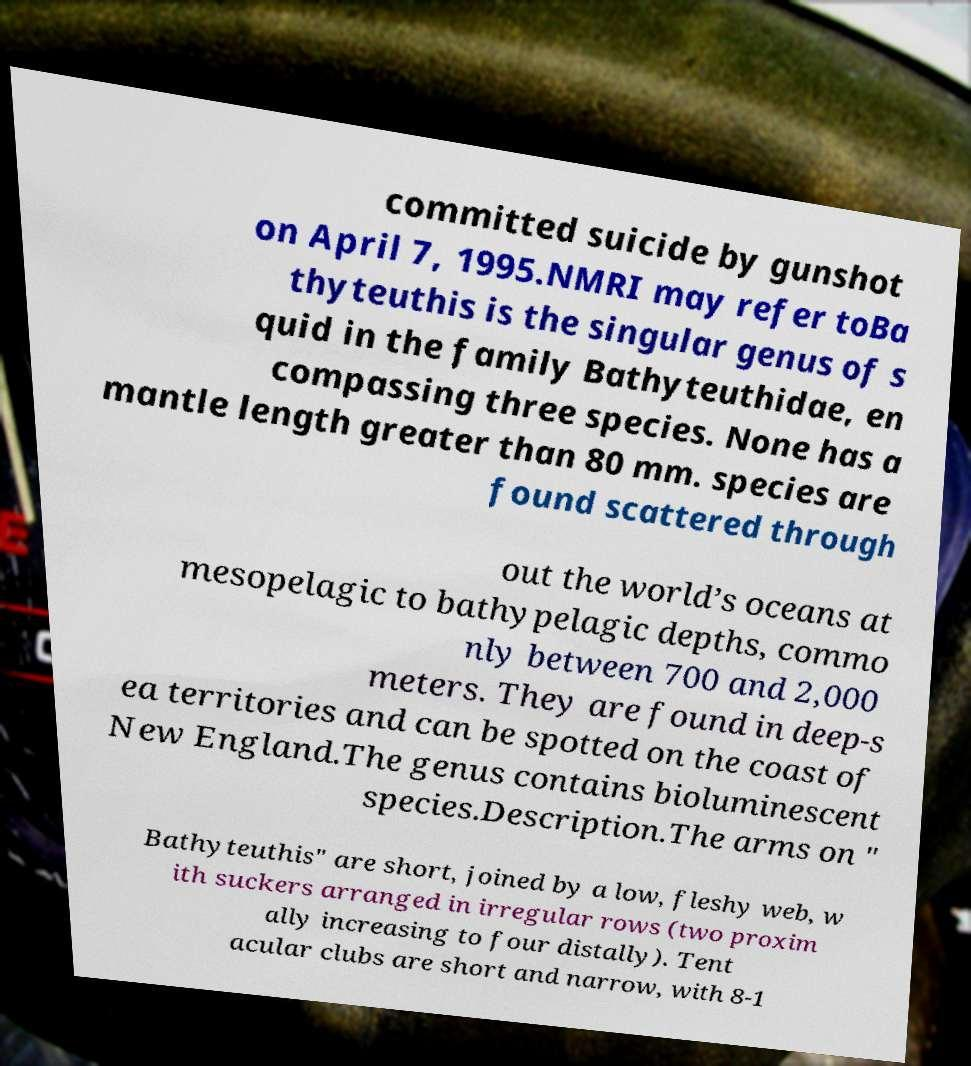Could you assist in decoding the text presented in this image and type it out clearly? committed suicide by gunshot on April 7, 1995.NMRI may refer toBa thyteuthis is the singular genus of s quid in the family Bathyteuthidae, en compassing three species. None has a mantle length greater than 80 mm. species are found scattered through out the world’s oceans at mesopelagic to bathypelagic depths, commo nly between 700 and 2,000 meters. They are found in deep-s ea territories and can be spotted on the coast of New England.The genus contains bioluminescent species.Description.The arms on " Bathyteuthis" are short, joined by a low, fleshy web, w ith suckers arranged in irregular rows (two proxim ally increasing to four distally). Tent acular clubs are short and narrow, with 8-1 